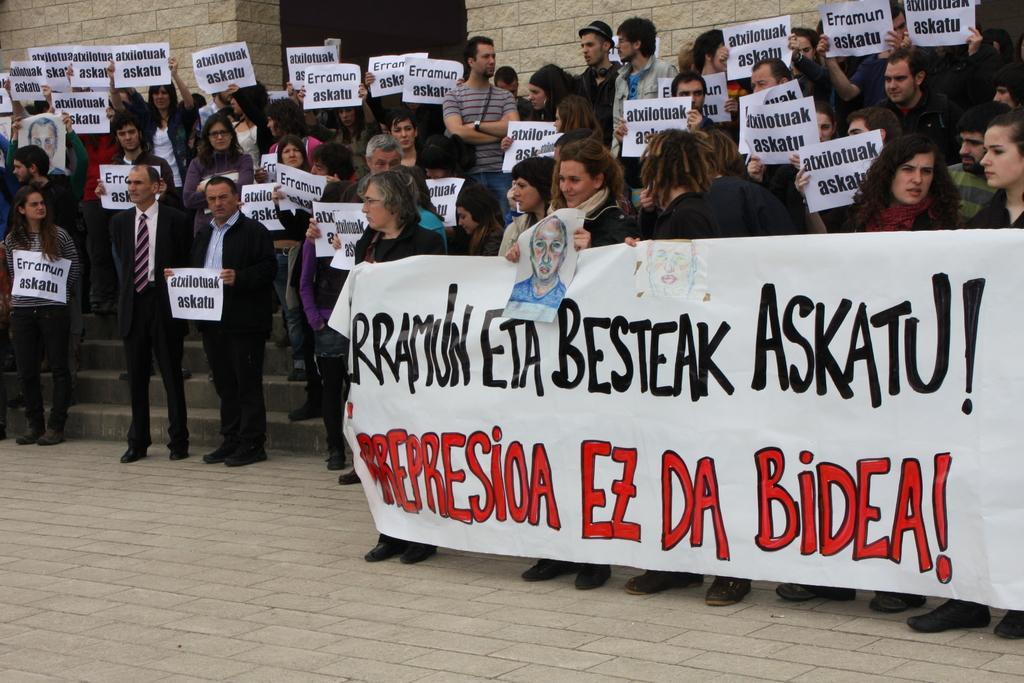How would you summarize this image in a sentence or two? Here in this picture we can see number of people standing over a place and some men are wearing suits and in the front we can see some people are carrying banner with something written on it and the woman in the middle is also carrying a sketch present on a paper and all the other people are carrying papers with something printed on it and protesting there. 